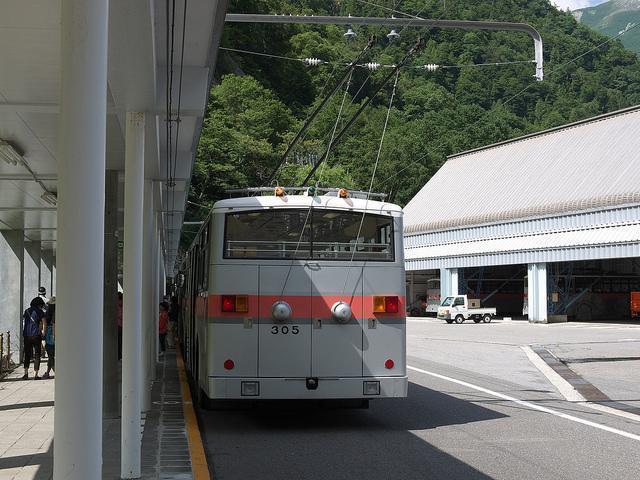How many buses are in the picture?
Give a very brief answer. 1. How many buses are there?
Give a very brief answer. 1. How many train tracks are empty?
Give a very brief answer. 0. 